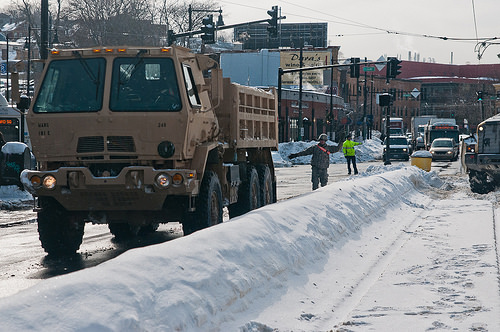<image>
Can you confirm if the snow bin is next to the man? Yes. The snow bin is positioned adjacent to the man, located nearby in the same general area. Is there a man in front of the truck? No. The man is not in front of the truck. The spatial positioning shows a different relationship between these objects. 